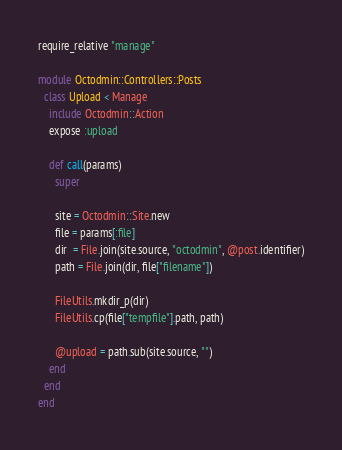<code> <loc_0><loc_0><loc_500><loc_500><_Ruby_>require_relative "manage"

module Octodmin::Controllers::Posts
  class Upload < Manage
    include Octodmin::Action
    expose :upload

    def call(params)
      super

      site = Octodmin::Site.new
      file = params[:file]
      dir  = File.join(site.source, "octodmin", @post.identifier)
      path = File.join(dir, file["filename"])

      FileUtils.mkdir_p(dir)
      FileUtils.cp(file["tempfile"].path, path)

      @upload = path.sub(site.source, "")
    end
  end
end
</code> 